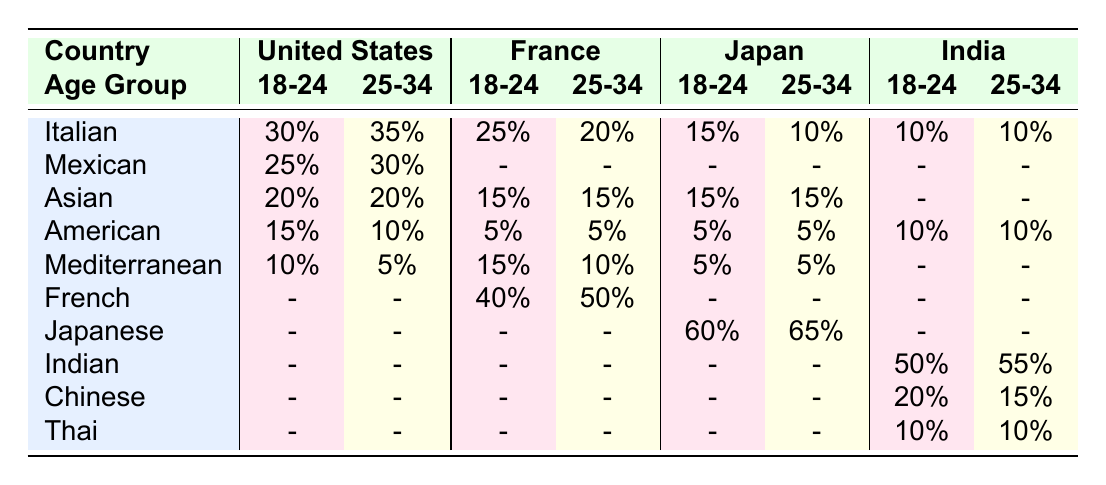What is the most preferred cuisine among 18-24 year-olds in Japan? In the table, looking at the row for 'Japanese' under the '18-24' age group for Japan, the percentage is 60%. Therefore, the most preferred cuisine for this age group is Japanese cuisine.
Answer: Japanese What percentage of French 25-34 year-olds prefer Italian cuisine? Referring to the table, in the French column for the age group 25-34, the percentage for Italian cuisine is 20%.
Answer: 20% In which country do 25-34 year-olds show the highest preference for Japanese cuisine? The table indicates that Japanese cuisine is only preferred by the younger age groups, specifically in Japan, where the preference is 65% for the 25-34 age group. Other countries do not have a preference for Japanese cuisine in this age group.
Answer: Japan What is the sum of cuisine preferences for American cuisine across all countries for the 18-24 age group? In the table, American cuisine preference for 18-24 year-olds is 15% in the United States and 5% in France, 5% in Japan, and 10% in India. Adding these percentages gives: 15 + 5 + 5 + 10 = 35%.
Answer: 35% Is there any country where Indian cuisine is preferred by 18-24 year-olds? Checking the table, we see that Indian cuisine appears only in the India row for the 18-24 age group, with a preference of 50%. Hence, yes, there is a country (India) where Indian cuisine is preferred by this age group.
Answer: Yes Which age group in India has a higher preference for Chinese cuisine, and what is the percentage? Looking at India, for the 18-24 age group, the preference for Chinese cuisine is 20%, while for the 25-34 age group, it is 15%. Therefore, the 18-24 age group has a higher preference for Chinese cuisine with a percentage of 20%.
Answer: 18-24 age group, 20% What is the average preference across all countries for Mediterranean cuisine? Adding the percentages for Mediterranean cuisine across all countries: 10% (US) + 5% (US) + 15% (France) + 10% (France) + 5% (Japan) + 5% (Japan) + 0% (India) + 0% (India) = 50%. There are four countries that have Mediterranean cuisine data, so the average is 50% / 4 = 12.5%.
Answer: 12.5% Is the preference for Mexican cuisine the same for both age groups in the United States? In the table, the preference for Mexican cuisine in the United States is 25% for the 18-24 age group and 30% for the 25-34 age group. Therefore, the preference is not the same for both age groups, as they differ by 5%.
Answer: No 